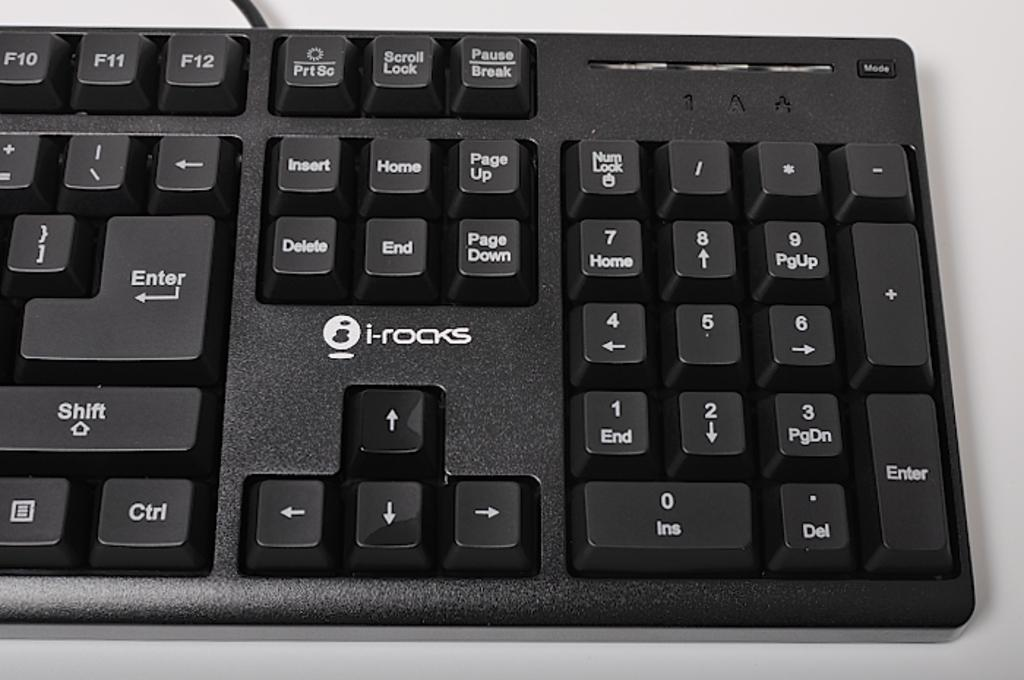<image>
Offer a succinct explanation of the picture presented. An i-rocks brand keyboard is black with white lettering on the keys. 